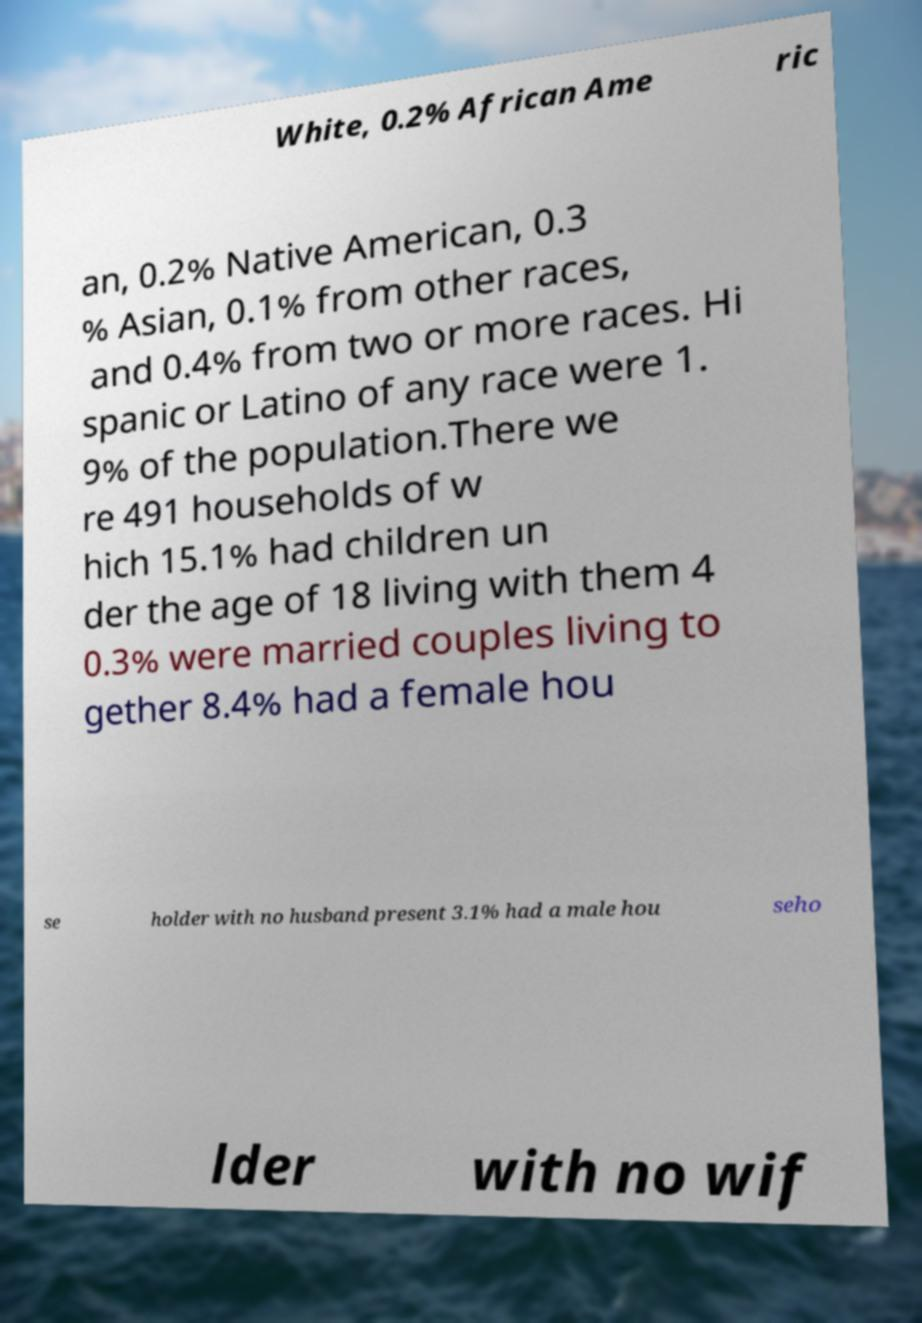Can you accurately transcribe the text from the provided image for me? White, 0.2% African Ame ric an, 0.2% Native American, 0.3 % Asian, 0.1% from other races, and 0.4% from two or more races. Hi spanic or Latino of any race were 1. 9% of the population.There we re 491 households of w hich 15.1% had children un der the age of 18 living with them 4 0.3% were married couples living to gether 8.4% had a female hou se holder with no husband present 3.1% had a male hou seho lder with no wif 